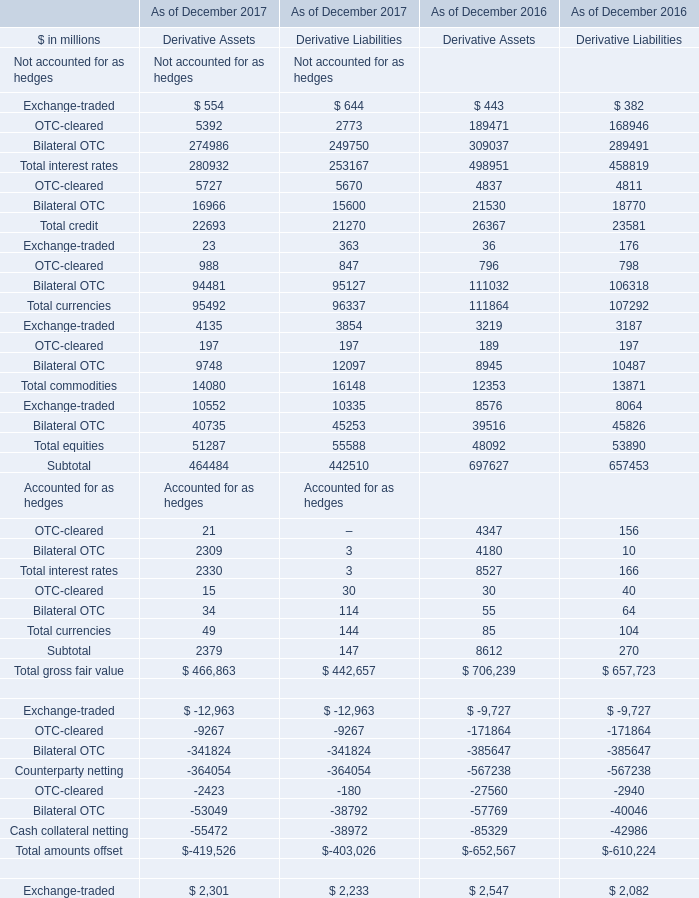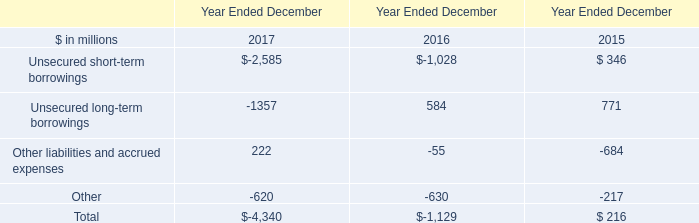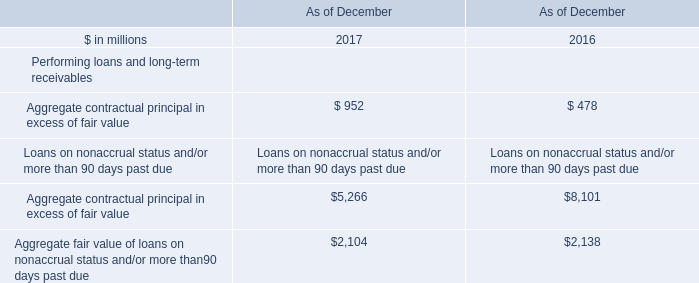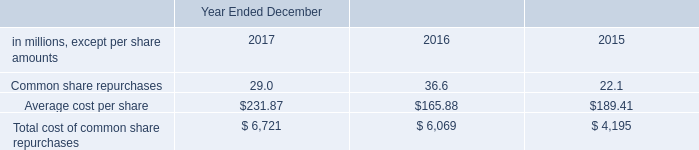what was the percentage change in dividends declared per common share between 2015 and 2016? 
Computations: ((2.60 - 2.55) / 2.55)
Answer: 0.01961. 